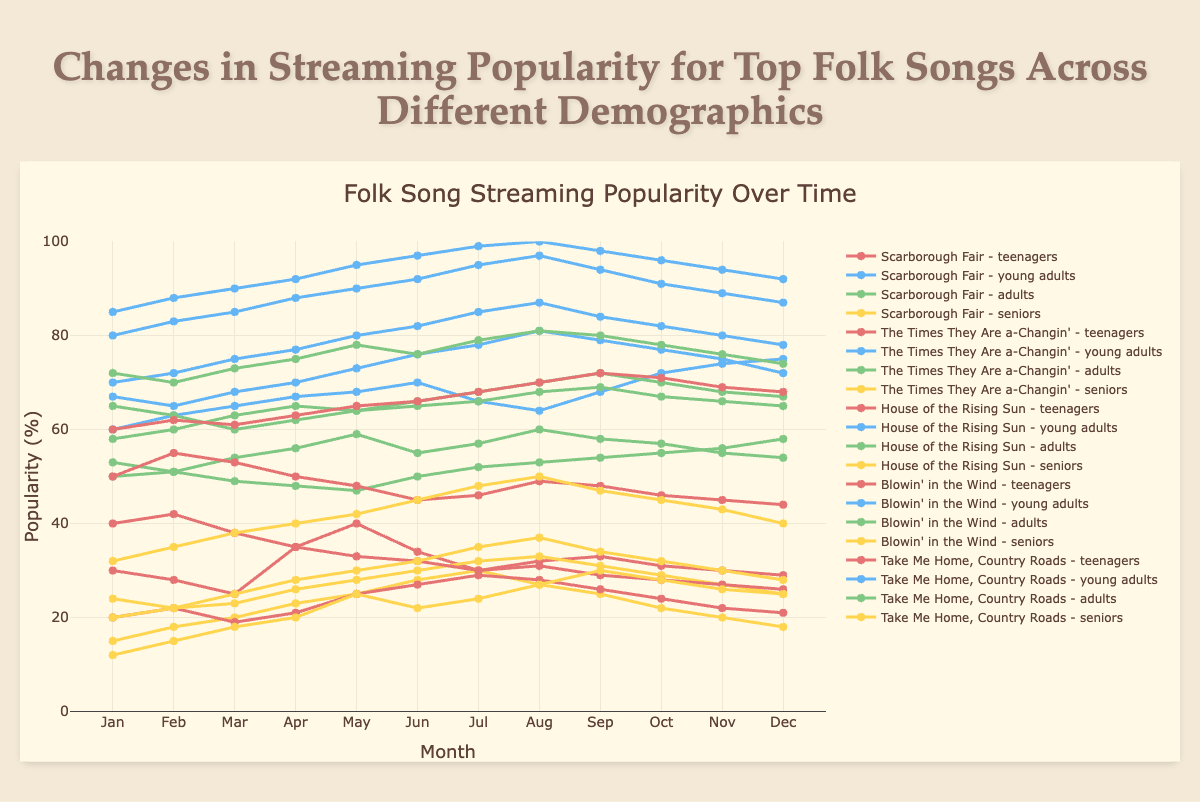What's the overall trend in the popularity of "Scarborough Fair" among teenagers from January to December? The popularity of "Scarborough Fair" among teenagers varies throughout the year, with some fluctuations. It starts at 30 in January, drops slightly to 28 and 25 in February and March, peaks at 40 in May, and settles back down to around 29 by December.
Answer: Slight upward trend with fluctuations Which demographic showed the highest maximum popularity for "Take Me Home, Country Roads" and during which month? Looking at the data for "Take Me Home, Country Roads," the young adults demographic shows the highest maximum popularity reaching 100 in August.
Answer: Young adults, August Compare the popularity of "House of the Rising Sun" in March for teenagers and seniors. Who had a higher popularity and by how much? For "House of the Rising Sun" in March, the popularity among teenagers was 38, while for seniors it was 18. To find out who had a higher popularity and by how much, we subtract the senior's popularity from the teenager's: 38 - 18 = 20.
Answer: Teenagers, by 20 What is the average popularity of "Blowin' in the Wind" across all demographics in June? To find the average, sum the popularity values for all demographics in June and divide by the number of demographics. The values are teenagers: 45, young adults: 92, adults: 66, and seniors: 32. So, the calculation is (45 + 92 + 66 + 32) / 4 = 235 / 4 = 58.75.
Answer: 58.75 Which song's popularity increased the most among seniors from January to December? By examining the data for seniors, we see that "Scarborough Fair" increased from 15 to 18 and "The Times They Are a-Changin'" from 24 to 25. "House of the Rising Sun" increased from 12 to 25, and "Blowin' in the Wind" from 20 to 28. "Take Me Home, Country Roads" increased from 32 to 40. The largest increase is 13 (House of the Rising Sun).
Answer: House of the Rising Sun Identify the song and demographic that had the lowest popularity in January and state the value. By examining each song and demographic for January: "Scarborough Fair" (teenagers: 30, young adults: 60, adults: 50, seniors: 15), "The Times They Are a-Changin'" (teenagers: 20, young adults: 67, adults: 53, seniors: 24), "House of the Rising Sun" (teenagers: 40, young adults: 70, adults: 65, seniors: 12), "Blowin' in the Wind" (teenagers: 50, young adults: 80, adults: 58, seniors: 20), and "Take Me Home, Country Roads" (teenagers: 60, young adults: 85, adults: 72, seniors: 32). The lowest is 12 for "House of the Rising Sun" among seniors.
Answer: House of the Rising Sun (seniors), 12 What is the range of popularity for adults for the song "The Times They Are a-Changin'"? Calculate the range by subtracting the minimum value from the maximum value for adults' popularity for "The Times They Are a-Changin'". The popularity values are 53, 51, 54, 56, 59, 55, 57, 60, 58, 57, 55, 54, so the range is 60 - 51 = 9.
Answer: 9 During which month did "Blowin' in the Wind" have the highest popularity among young adults, and what was the popularity percentage? By looking at the data for young adults regarding "Blowin' in the Wind", the highest popularity is 97 in August.
Answer: August, 97 